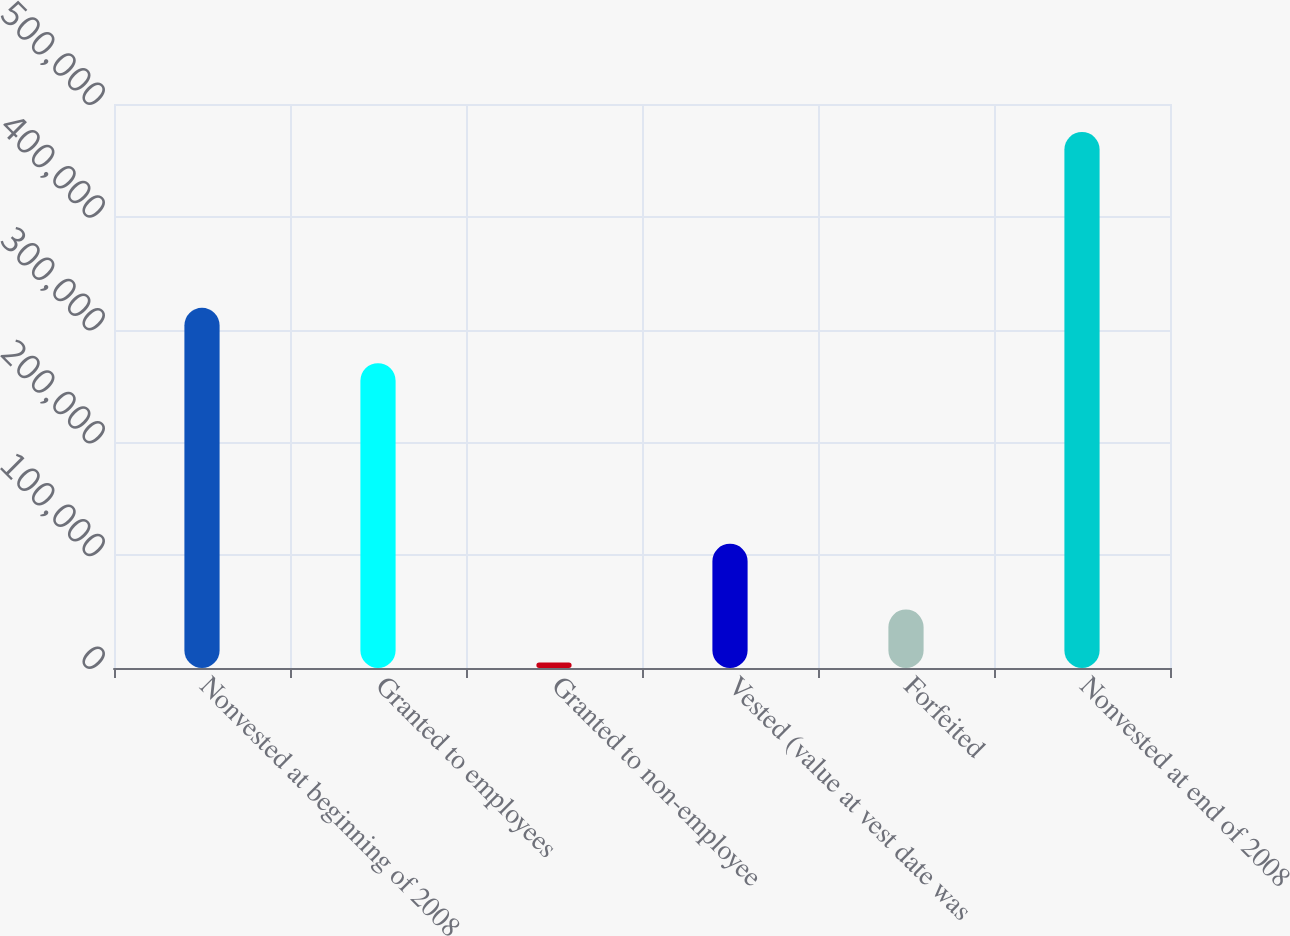<chart> <loc_0><loc_0><loc_500><loc_500><bar_chart><fcel>Nonvested at beginning of 2008<fcel>Granted to employees<fcel>Granted to non-employee<fcel>Vested (value at vest date was<fcel>Forfeited<fcel>Nonvested at end of 2008<nl><fcel>319300<fcel>270250<fcel>4800<fcel>110168<fcel>51839.4<fcel>475194<nl></chart> 